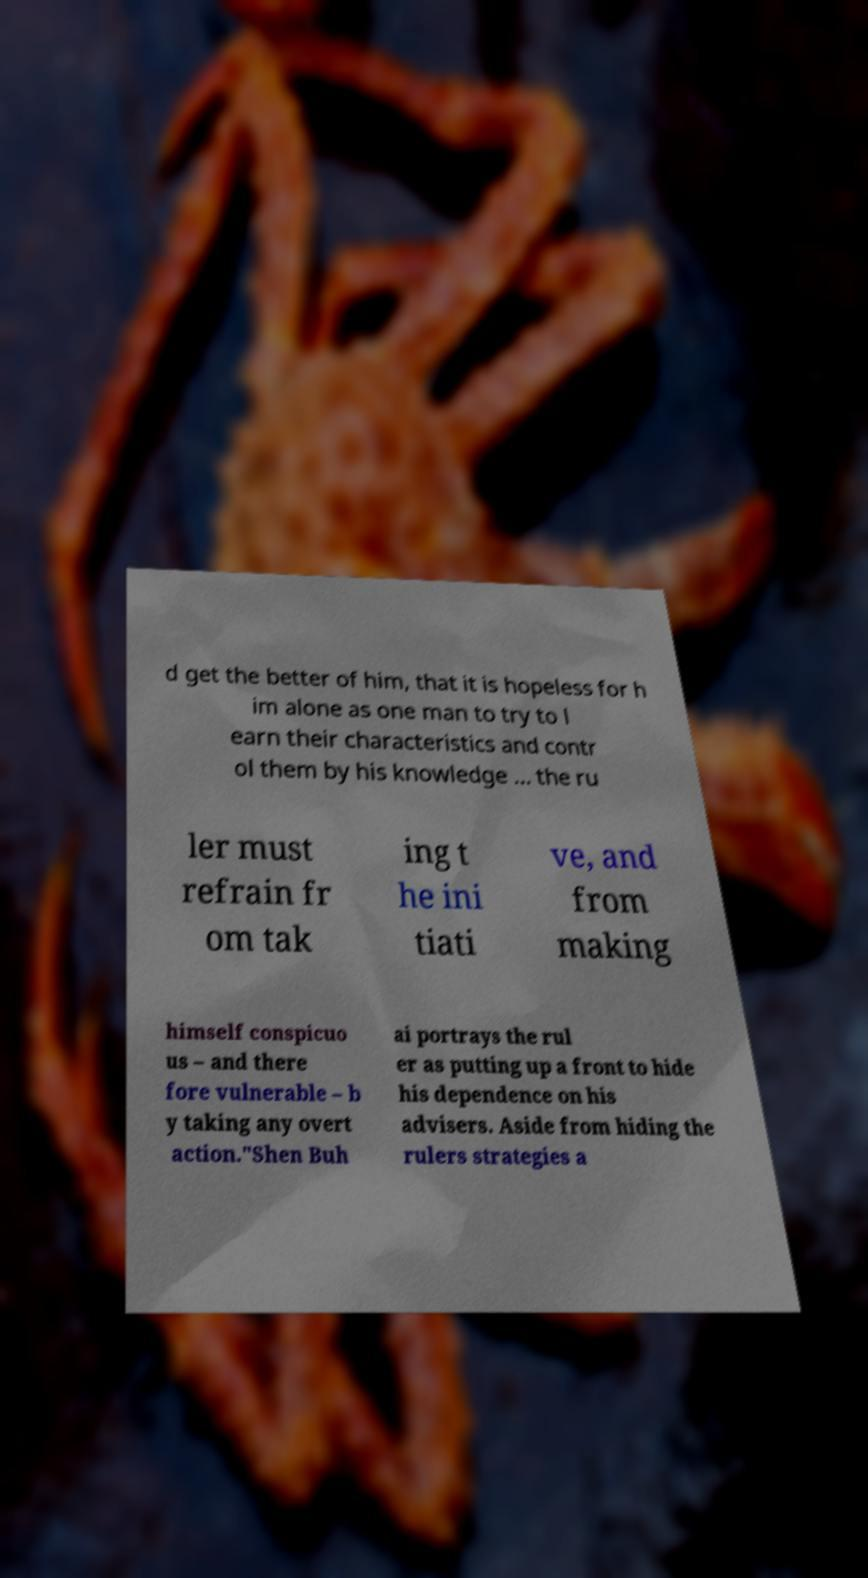There's text embedded in this image that I need extracted. Can you transcribe it verbatim? d get the better of him, that it is hopeless for h im alone as one man to try to l earn their characteristics and contr ol them by his knowledge ... the ru ler must refrain fr om tak ing t he ini tiati ve, and from making himself conspicuo us – and there fore vulnerable – b y taking any overt action."Shen Buh ai portrays the rul er as putting up a front to hide his dependence on his advisers. Aside from hiding the rulers strategies a 